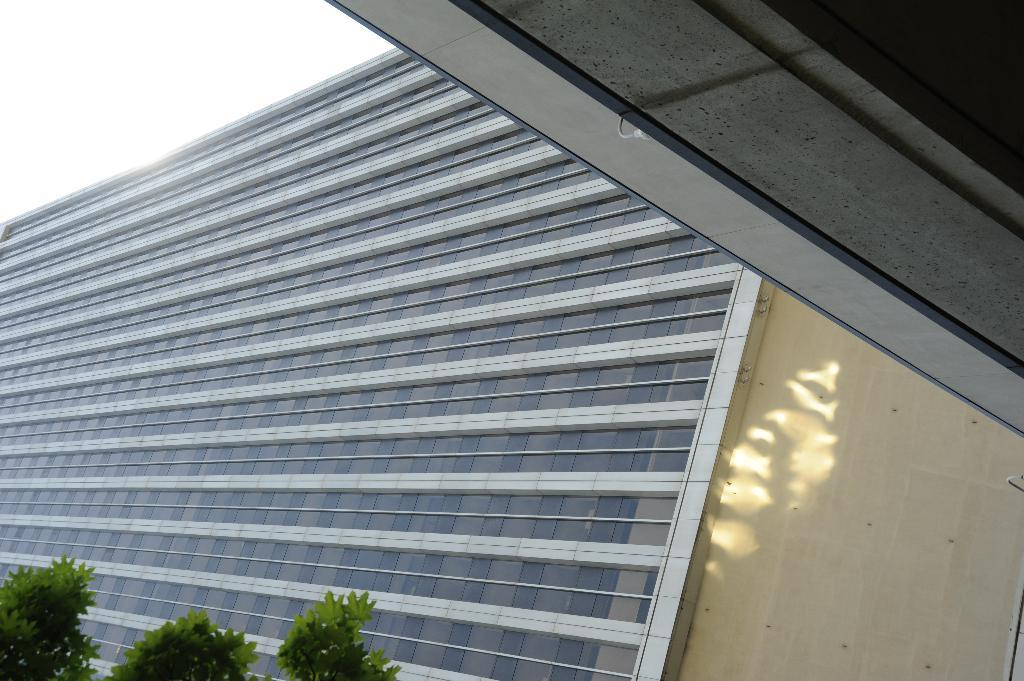What is located at the top right side of the image? There is a roof at the top right side of the image. What can be seen in the background of the image? The sky, at least one building, a wall, glass, and branches with leaves are visible in the background of the image. What type of insect can be seen biting the wall in the image? There is no insect present in the image, and therefore no biting can be observed. 